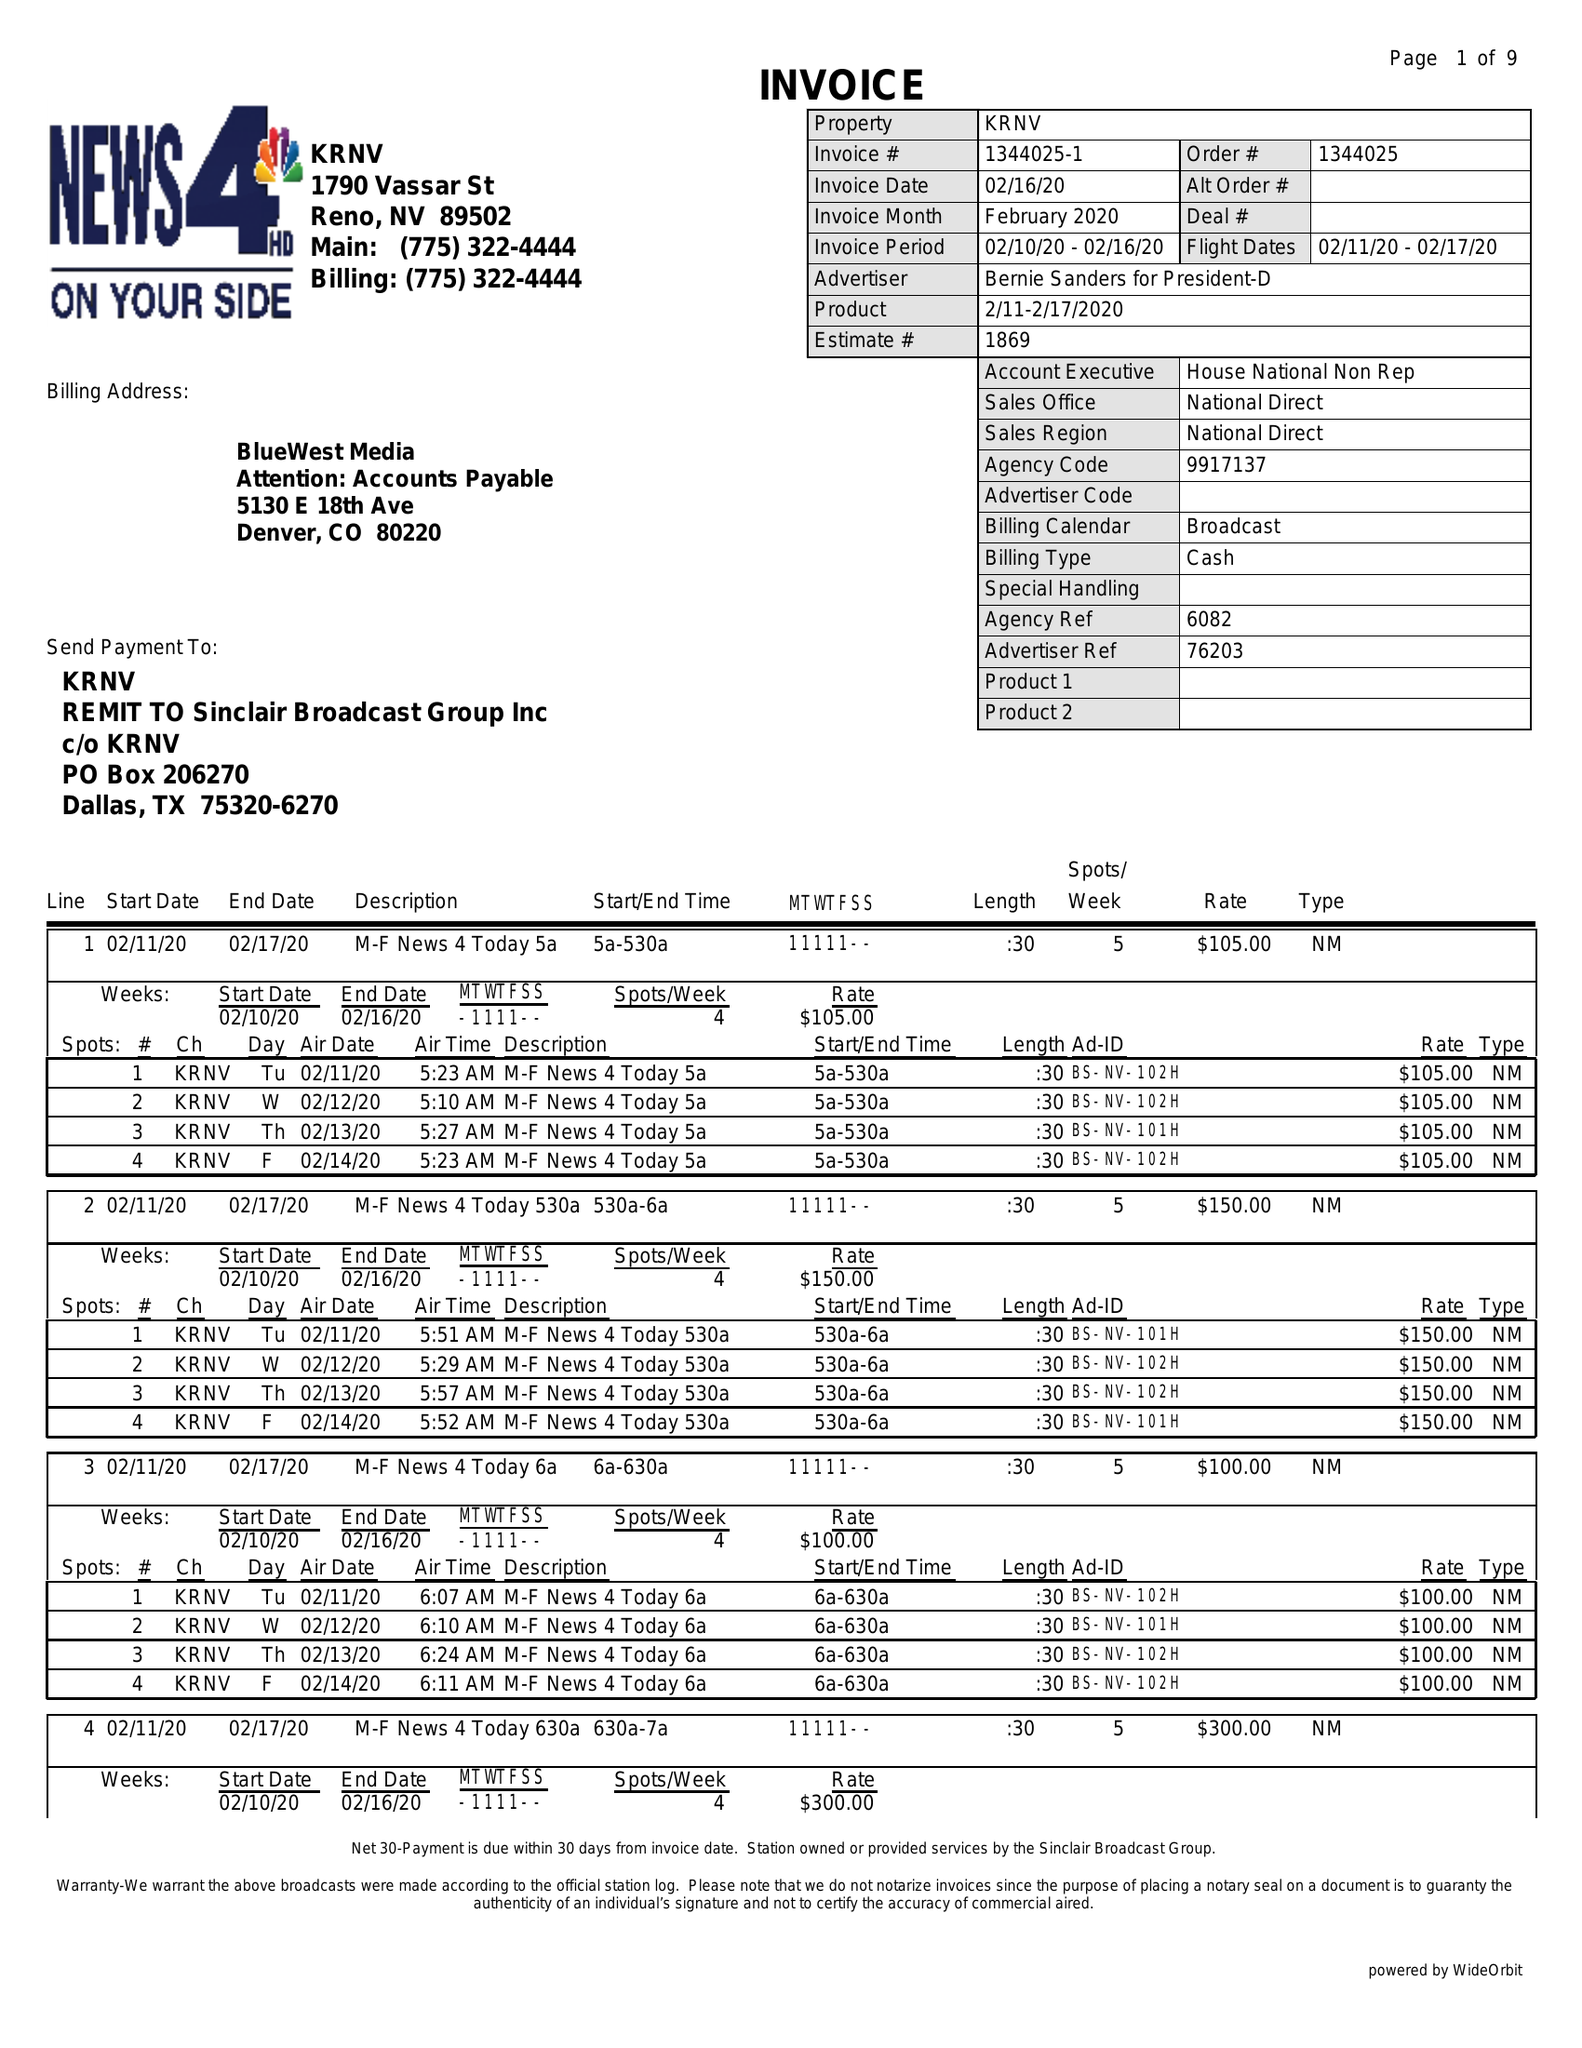What is the value for the advertiser?
Answer the question using a single word or phrase. BERNIE SANDERS FOR PRESIDENT-D 